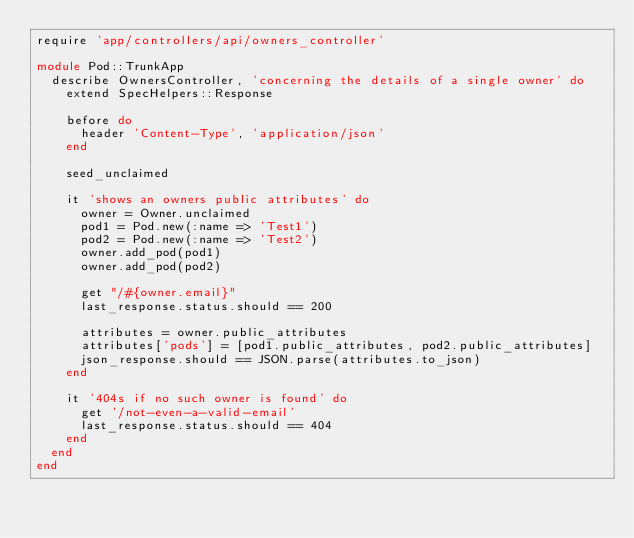<code> <loc_0><loc_0><loc_500><loc_500><_Ruby_>require 'app/controllers/api/owners_controller'

module Pod::TrunkApp
  describe OwnersController, 'concerning the details of a single owner' do
    extend SpecHelpers::Response

    before do
      header 'Content-Type', 'application/json'
    end

    seed_unclaimed

    it 'shows an owners public attributes' do
      owner = Owner.unclaimed
      pod1 = Pod.new(:name => 'Test1')
      pod2 = Pod.new(:name => 'Test2')
      owner.add_pod(pod1)
      owner.add_pod(pod2)

      get "/#{owner.email}"
      last_response.status.should == 200

      attributes = owner.public_attributes
      attributes['pods'] = [pod1.public_attributes, pod2.public_attributes]
      json_response.should == JSON.parse(attributes.to_json)
    end

    it '404s if no such owner is found' do
      get '/not-even-a-valid-email'
      last_response.status.should == 404
    end
  end
end
</code> 